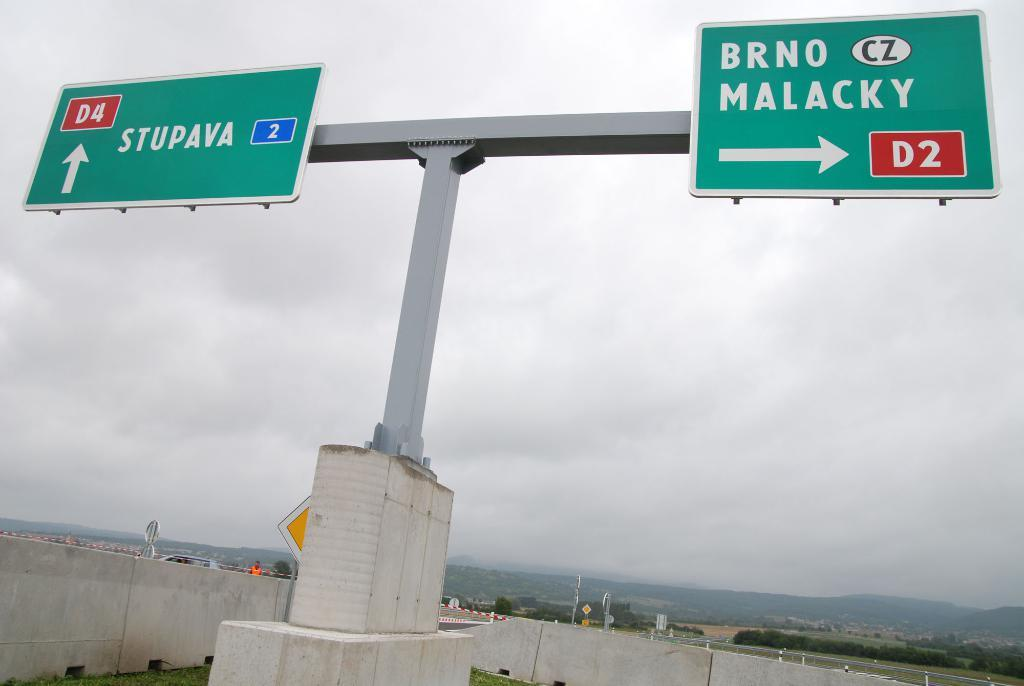Provide a one-sentence caption for the provided image. A road sign indicates that drivers need to go right to get to BRNO MALACKY. 